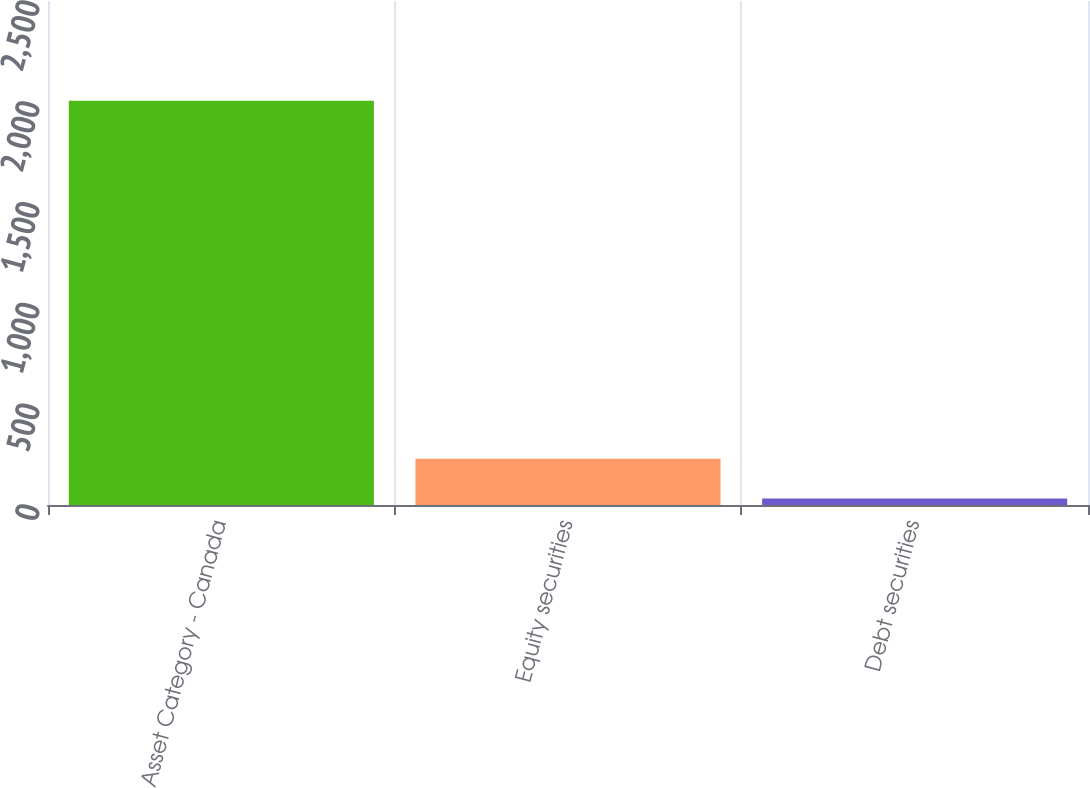<chart> <loc_0><loc_0><loc_500><loc_500><bar_chart><fcel>Asset Category - Canada<fcel>Equity securities<fcel>Debt securities<nl><fcel>2005<fcel>229.3<fcel>32<nl></chart> 